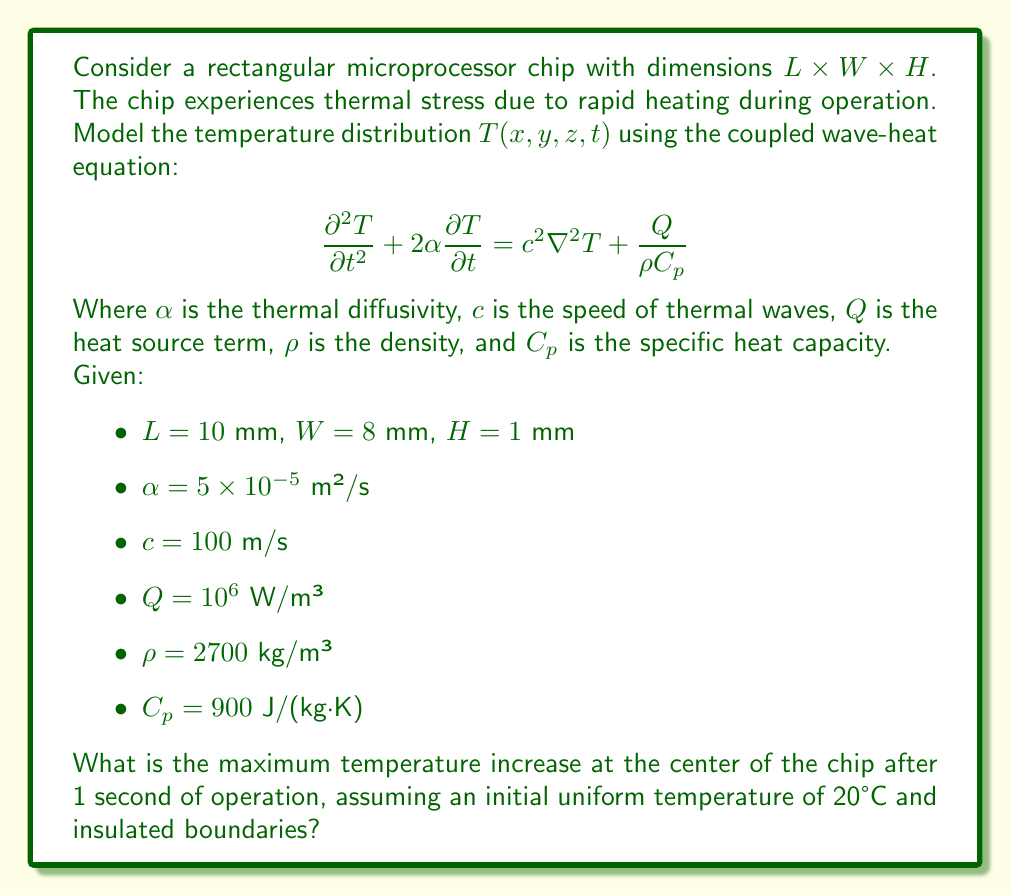Could you help me with this problem? To solve this problem, we'll follow these steps:

1) First, we need to simplify the equation for our specific case. Since we're interested in the center of the chip, we can assume symmetry and reduce the problem to a 1D case along the z-axis (thickness).

2) The simplified 1D equation becomes:

   $$\frac{\partial^2 T}{\partial t^2} + 2\alpha\frac{\partial T}{\partial t} = c^2\frac{\partial^2 T}{\partial z^2} + \frac{Q}{\rho C_p}$$

3) For the maximum temperature increase at the center, we can use the analytical solution for a 1D slab with insulated boundaries:

   $$T(z,t) = T_0 + \frac{Q}{2\rho C_p\alpha}(H^2/4 - z^2) + \frac{QH^2}{12\rho C_p\alpha}(1 - e^{-\alpha\pi^2t/H^2})$$

   Where $T_0$ is the initial temperature.

4) At the center, $z = 0$, and after 1 second, the equation becomes:

   $$T(0,1) = 20 + \frac{10^6}{2 \cdot 2700 \cdot 900 \cdot 5 \times 10^{-5}}(0.001^2/4) + \frac{10^6 \cdot 0.001^2}{12 \cdot 2700 \cdot 900 \cdot 5 \times 10^{-5}}(1 - e^{-5 \times 10^{-5}\pi^2/0.001^2})$$

5) Calculating each term:
   - Second term: $\approx 0.0231$ K
   - Third term: $\approx 0.0077$ K

6) Adding all terms:
   $T(0,1) \approx 20 + 0.0231 + 0.0077 = 20.0308$ K

7) The temperature increase is:
   $\Delta T = 20.0308 - 20 = 0.0308$ K
Answer: 0.0308 K 